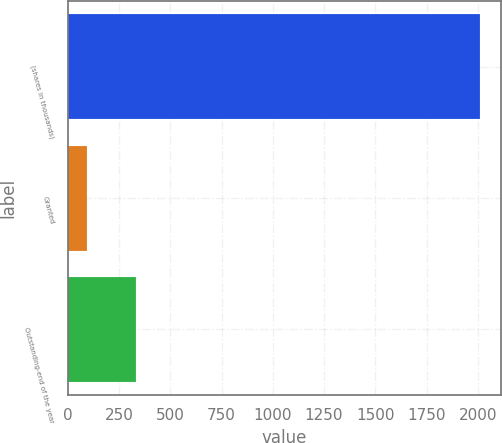Convert chart to OTSL. <chart><loc_0><loc_0><loc_500><loc_500><bar_chart><fcel>(shares in thousands)<fcel>Granted<fcel>Outstanding-end of the year<nl><fcel>2013<fcel>94<fcel>334<nl></chart> 